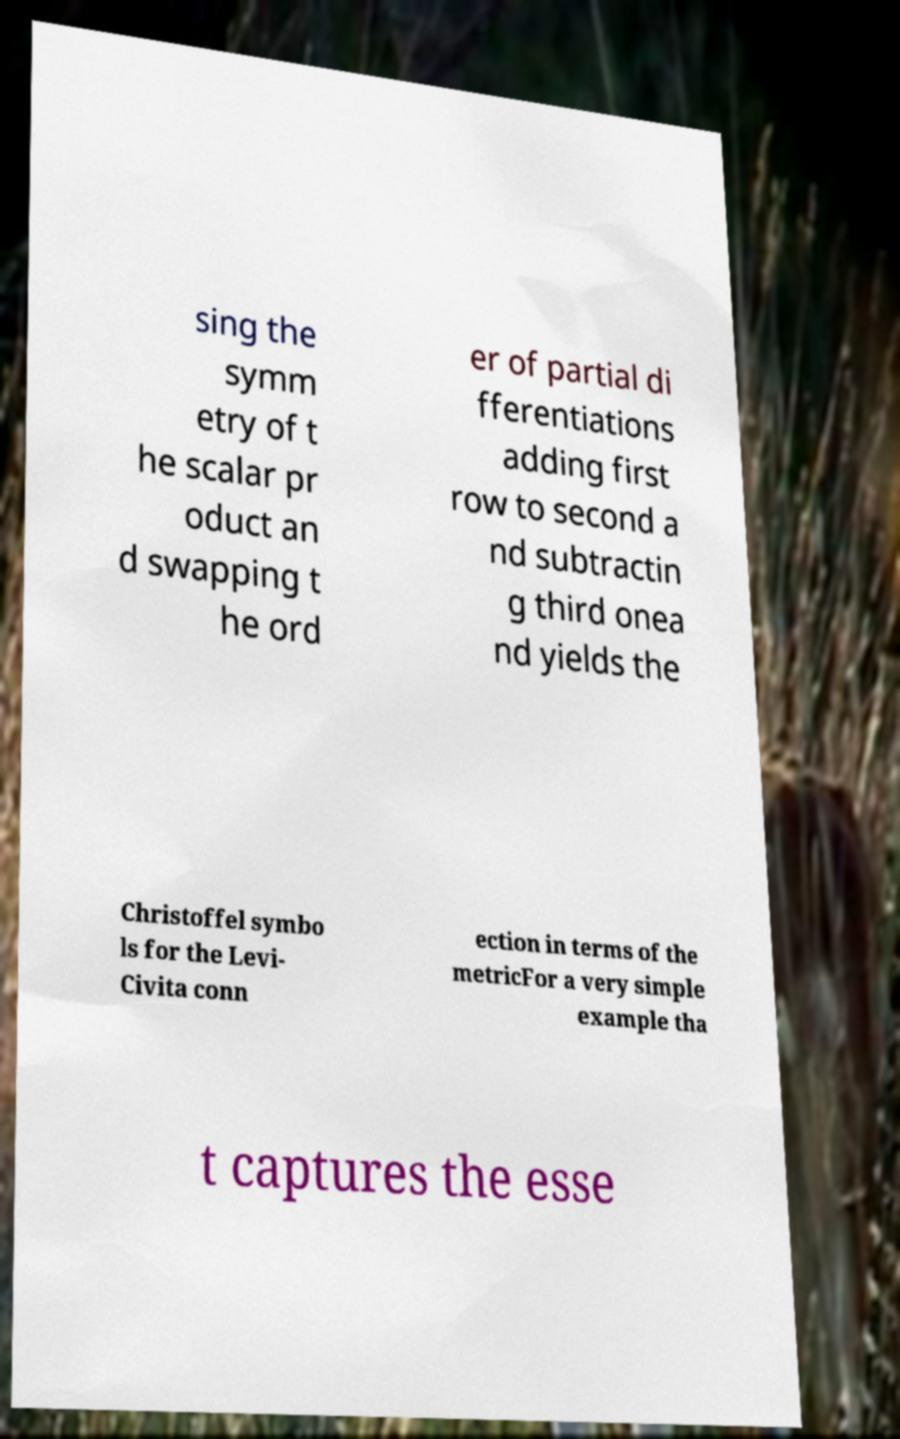Please read and relay the text visible in this image. What does it say? sing the symm etry of t he scalar pr oduct an d swapping t he ord er of partial di fferentiations adding first row to second a nd subtractin g third onea nd yields the Christoffel symbo ls for the Levi- Civita conn ection in terms of the metricFor a very simple example tha t captures the esse 